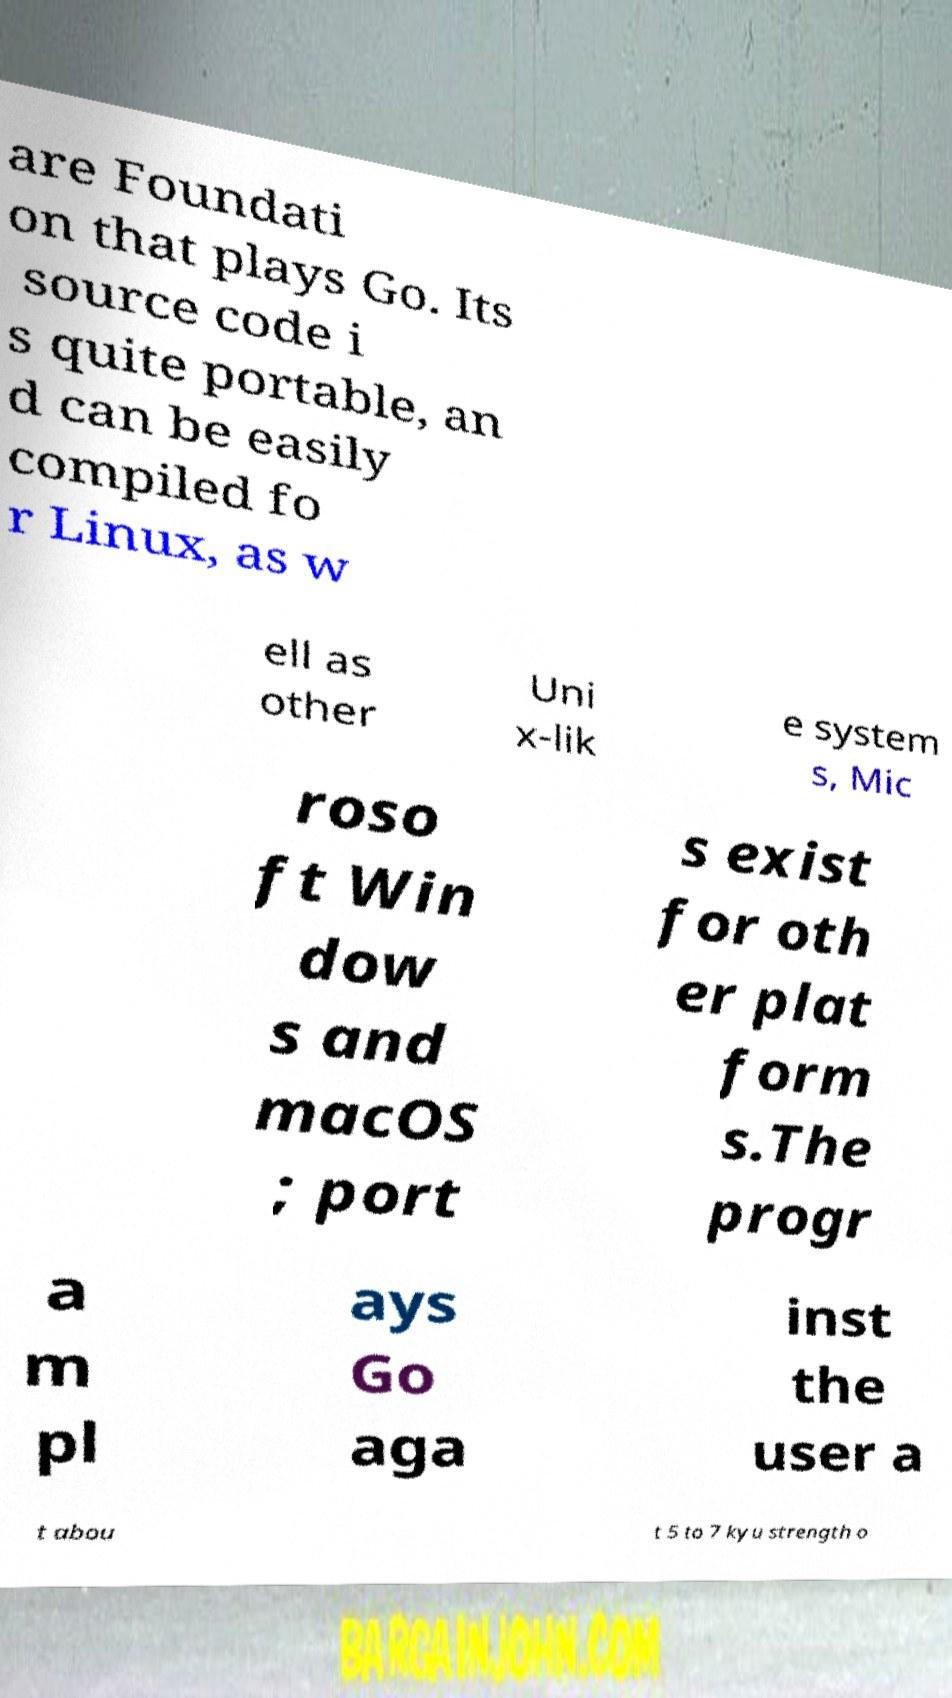For documentation purposes, I need the text within this image transcribed. Could you provide that? are Foundati on that plays Go. Its source code i s quite portable, an d can be easily compiled fo r Linux, as w ell as other Uni x-lik e system s, Mic roso ft Win dow s and macOS ; port s exist for oth er plat form s.The progr a m pl ays Go aga inst the user a t abou t 5 to 7 kyu strength o 